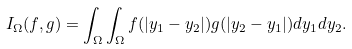<formula> <loc_0><loc_0><loc_500><loc_500>I _ { \Omega } ( f , g ) = \int _ { \Omega } \int _ { \Omega } f ( | y _ { 1 } - y _ { 2 } | ) g ( | y _ { 2 } - y _ { 1 } | ) d y _ { 1 } d y _ { 2 } .</formula> 